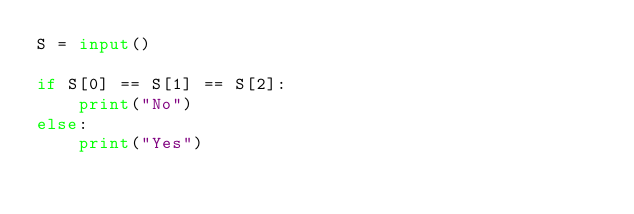<code> <loc_0><loc_0><loc_500><loc_500><_Python_>S = input()

if S[0] == S[1] == S[2]:
    print("No")
else:
    print("Yes")</code> 